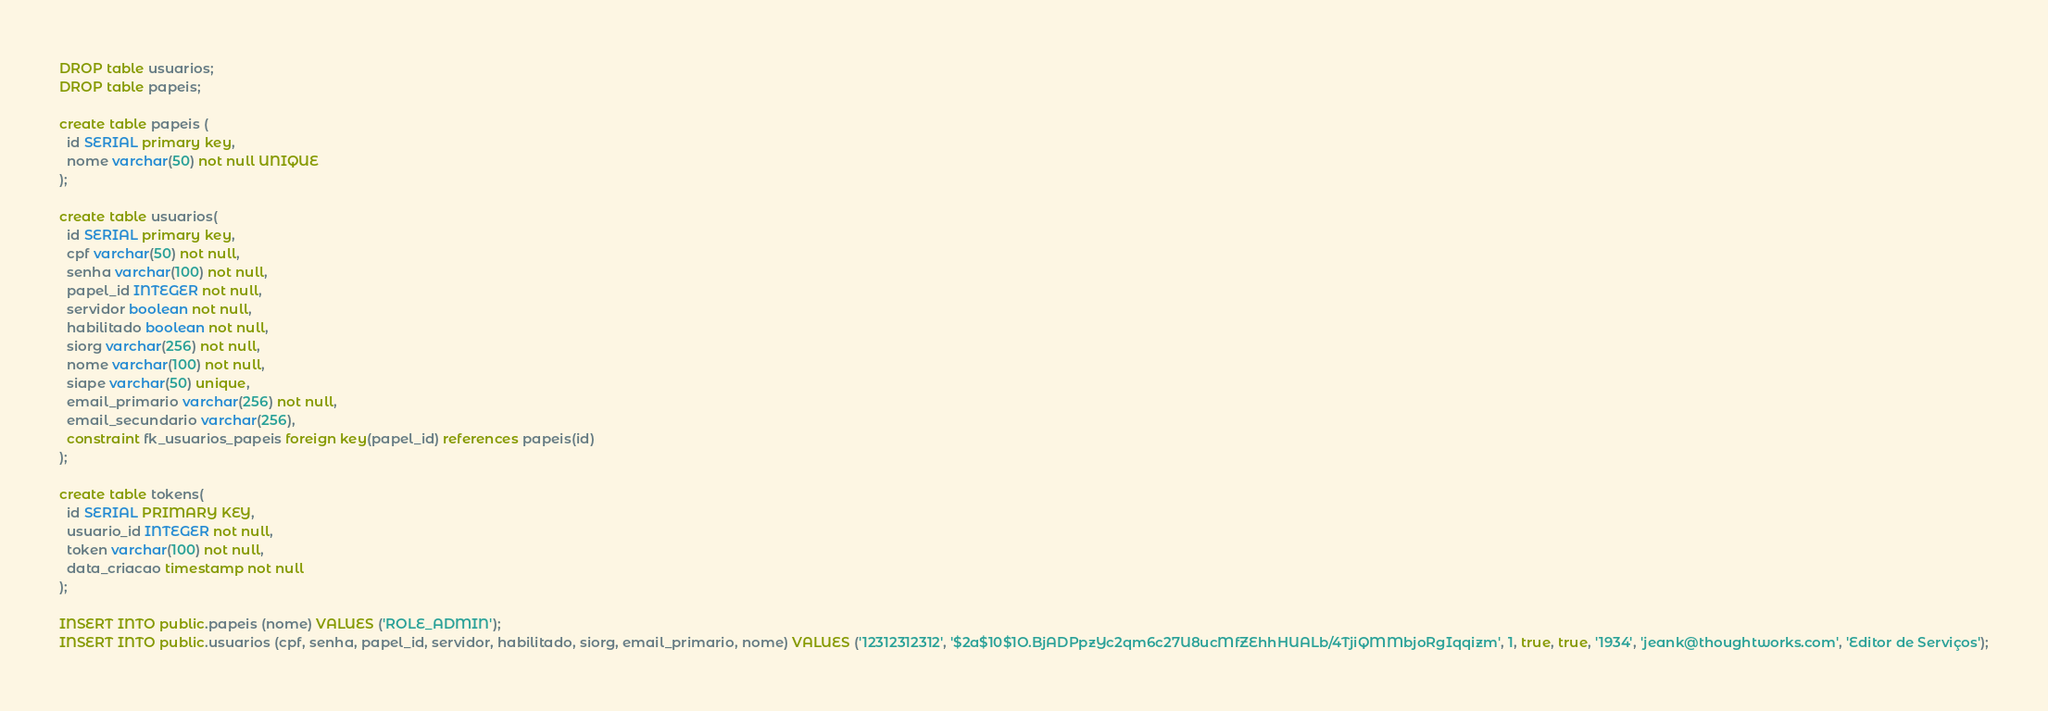Convert code to text. <code><loc_0><loc_0><loc_500><loc_500><_SQL_>DROP table usuarios;
DROP table papeis;

create table papeis (
  id SERIAL primary key,
  nome varchar(50) not null UNIQUE
);

create table usuarios(
  id SERIAL primary key,
  cpf varchar(50) not null,
  senha varchar(100) not null,
  papel_id INTEGER not null,
  servidor boolean not null,
  habilitado boolean not null,
  siorg varchar(256) not null,
  nome varchar(100) not null,
  siape varchar(50) unique,
  email_primario varchar(256) not null,
  email_secundario varchar(256),
  constraint fk_usuarios_papeis foreign key(papel_id) references papeis(id)
);

create table tokens(
  id SERIAL PRIMARY KEY,
  usuario_id INTEGER not null,
  token varchar(100) not null,
  data_criacao timestamp not null
);

INSERT INTO public.papeis (nome) VALUES ('ROLE_ADMIN');
INSERT INTO public.usuarios (cpf, senha, papel_id, servidor, habilitado, siorg, email_primario, nome) VALUES ('12312312312', '$2a$10$1O.BjADPpzYc2qm6c27U8ucMfZEhhHUALb/4TjiQMMbjoRgIqqizm', 1, true, true, '1934', 'jeank@thoughtworks.com', 'Editor de Serviços');
</code> 